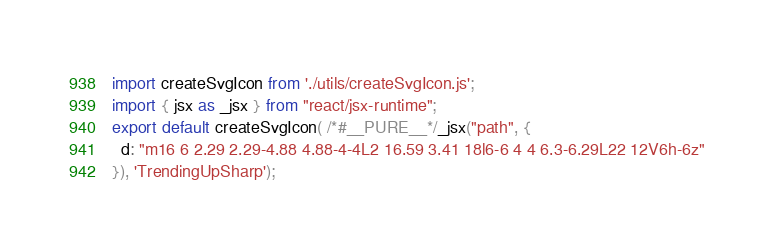Convert code to text. <code><loc_0><loc_0><loc_500><loc_500><_JavaScript_>import createSvgIcon from './utils/createSvgIcon.js';
import { jsx as _jsx } from "react/jsx-runtime";
export default createSvgIcon( /*#__PURE__*/_jsx("path", {
  d: "m16 6 2.29 2.29-4.88 4.88-4-4L2 16.59 3.41 18l6-6 4 4 6.3-6.29L22 12V6h-6z"
}), 'TrendingUpSharp');</code> 